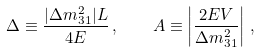<formula> <loc_0><loc_0><loc_500><loc_500>\Delta \equiv \frac { | \Delta m ^ { 2 } _ { 3 1 } | L } { 4 E } \, , \quad A \equiv \left | \frac { 2 E V } { \Delta m ^ { 2 } _ { 3 1 } } \right | \, ,</formula> 